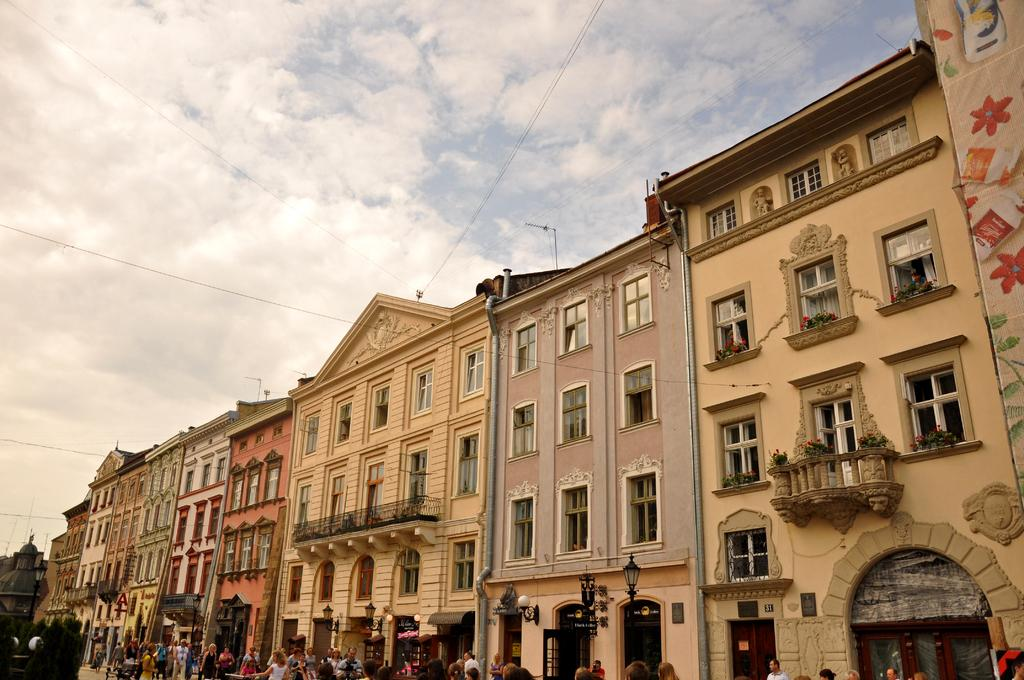What structures are located at the bottom of the image? There are buildings at the bottom of the image. Who or what else can be seen at the bottom of the image? There are persons at the bottom of the image. What can be seen illuminating the scene in the image? Lights are present in the image. What are the poles and wires used for in the image? The poles and wires are likely used for supporting and transmitting electrical or communication lines. What is visible at the top of the image? There is sky visible at the top of the image. What type of peace symbol can be seen hanging from the chain in the image? There is no chain or peace symbol present in the image. Can you tell me how many apples are on the buildings in the image? There are no apples present on the buildings in the image. 